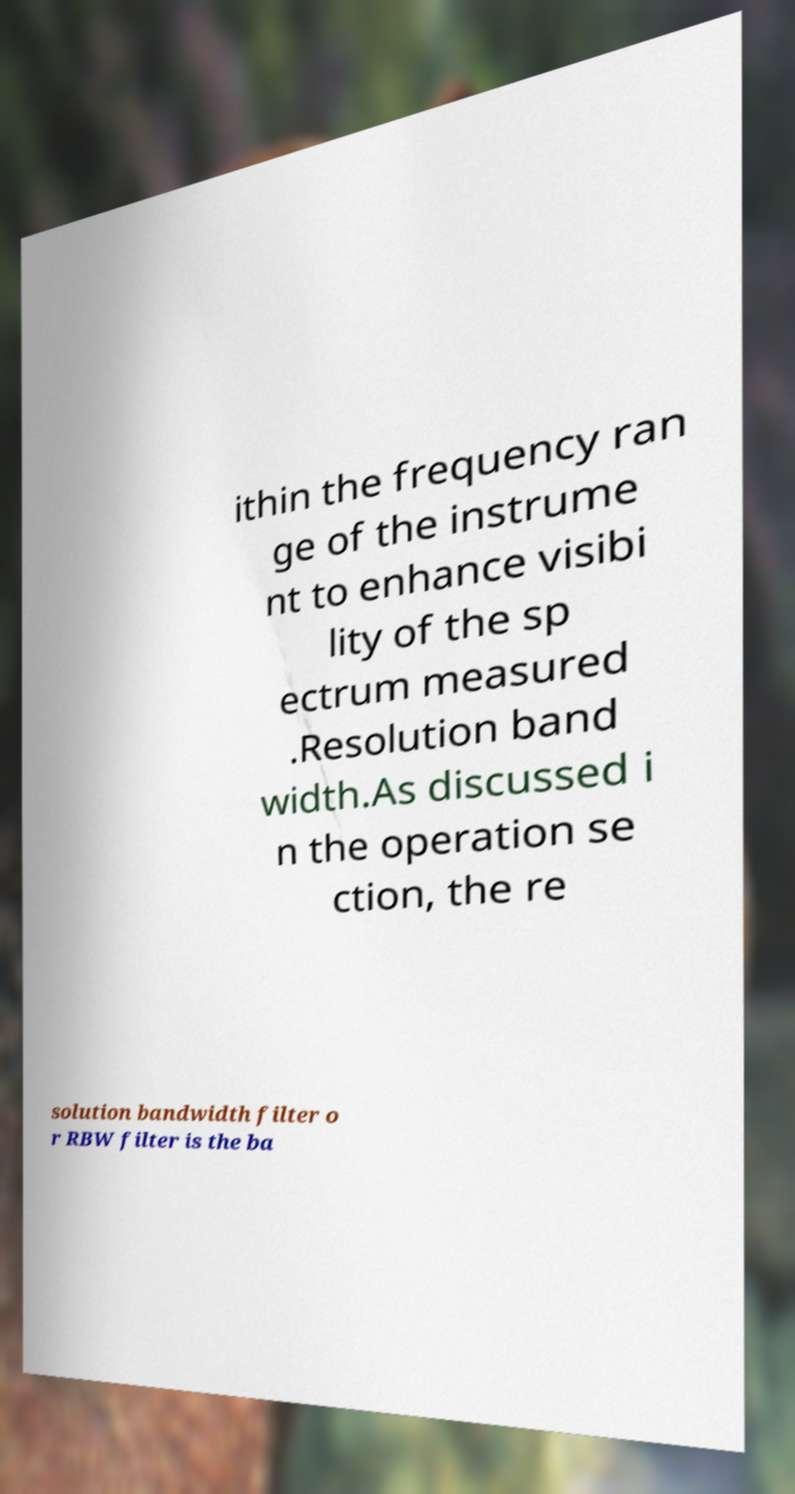I need the written content from this picture converted into text. Can you do that? ithin the frequency ran ge of the instrume nt to enhance visibi lity of the sp ectrum measured .Resolution band width.As discussed i n the operation se ction, the re solution bandwidth filter o r RBW filter is the ba 